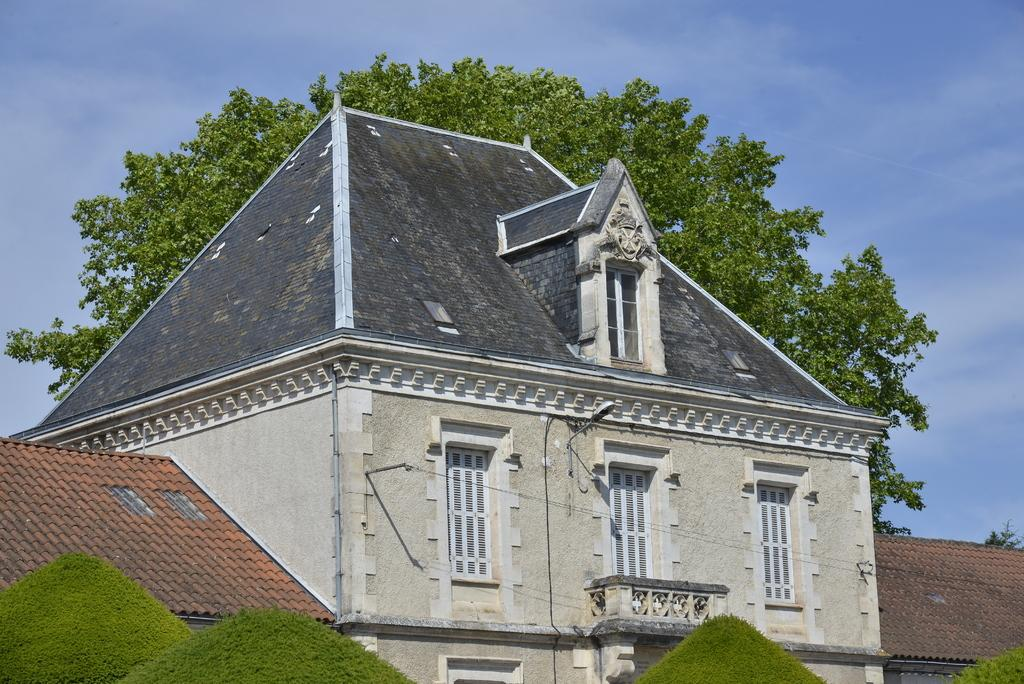What is located in the center of the image? There are buildings in the center of the image. What can be seen at the bottom of the image? There are trees at the bottom of the image. Can you describe the tree behind the building? There is another tree behind the building. What is visible at the top of the image? The sky is visible at the top of the image. What type of crown is worn by the tree in the image? There is no crown present in the image, as it features buildings, trees, and the sky. What shape is the substance that the buildings are made of in the image? There is no substance mentioned in the image, and the buildings' shapes are not described in the provided facts. 